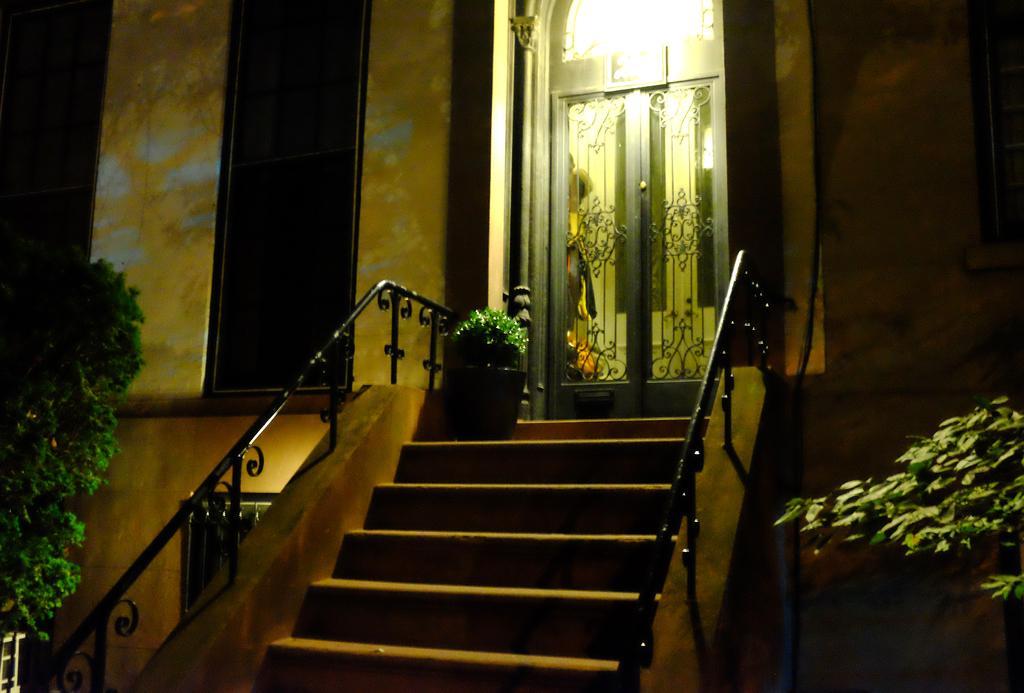How would you summarize this image in a sentence or two? In this image I see a building over here and I see the doors over here and I see the steps and I see few plants and I see the light. 